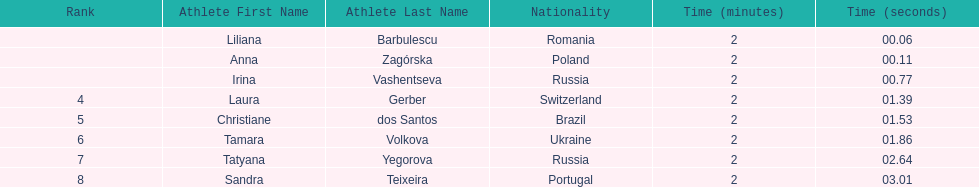Which south american country placed after irina vashentseva? Brazil. 